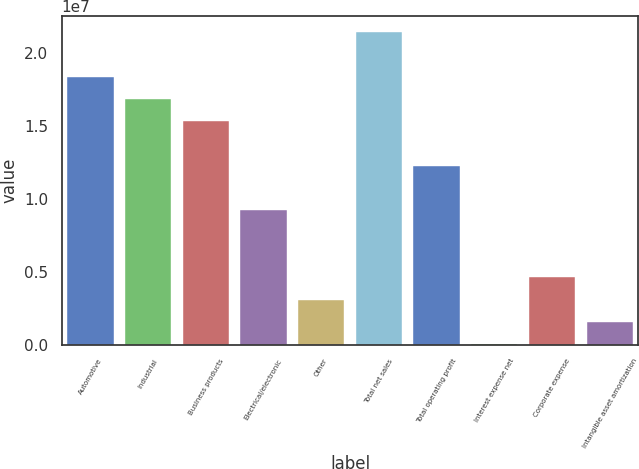Convert chart. <chart><loc_0><loc_0><loc_500><loc_500><bar_chart><fcel>Automotive<fcel>Industrial<fcel>Business products<fcel>Electrical/electronic<fcel>Other<fcel>Total net sales<fcel>Total operating profit<fcel>Interest expense net<fcel>Corporate expense<fcel>Intangible asset amortization<nl><fcel>1.84038e+07<fcel>1.68717e+07<fcel>1.53397e+07<fcel>9.21164e+06<fcel>3.08356e+06<fcel>2.14678e+07<fcel>1.22757e+07<fcel>19525<fcel>4.61558e+06<fcel>1.55154e+06<nl></chart> 